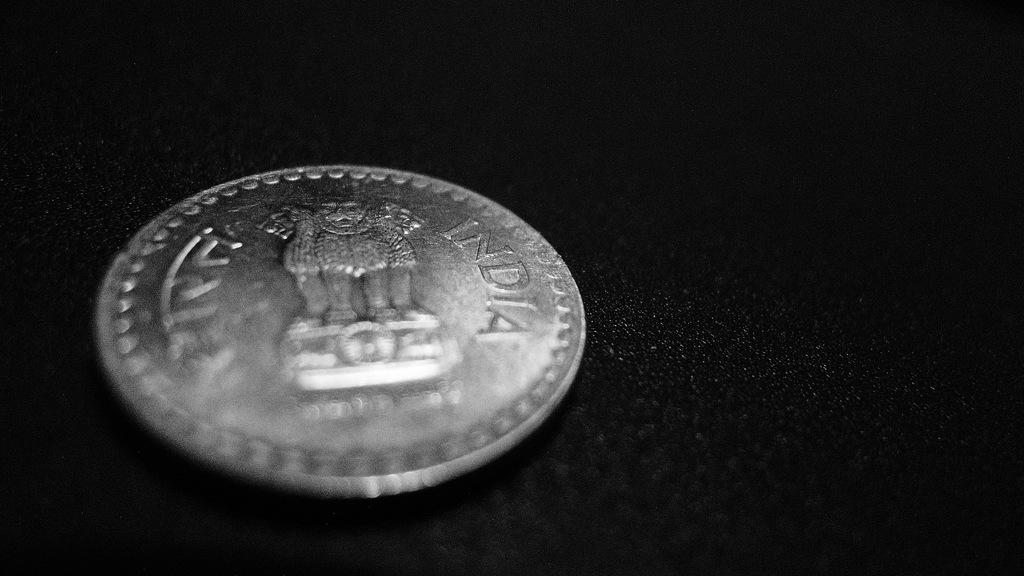<image>
Write a terse but informative summary of the picture. The silver coin on the table reads India 